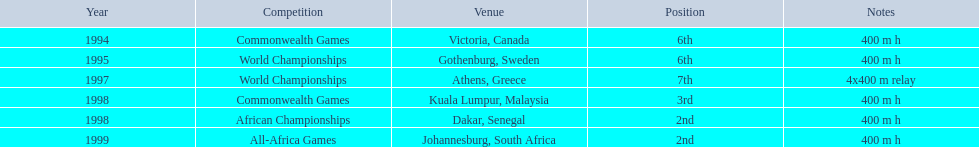In what year did ken harnden participate in more than one competition? 1998. 